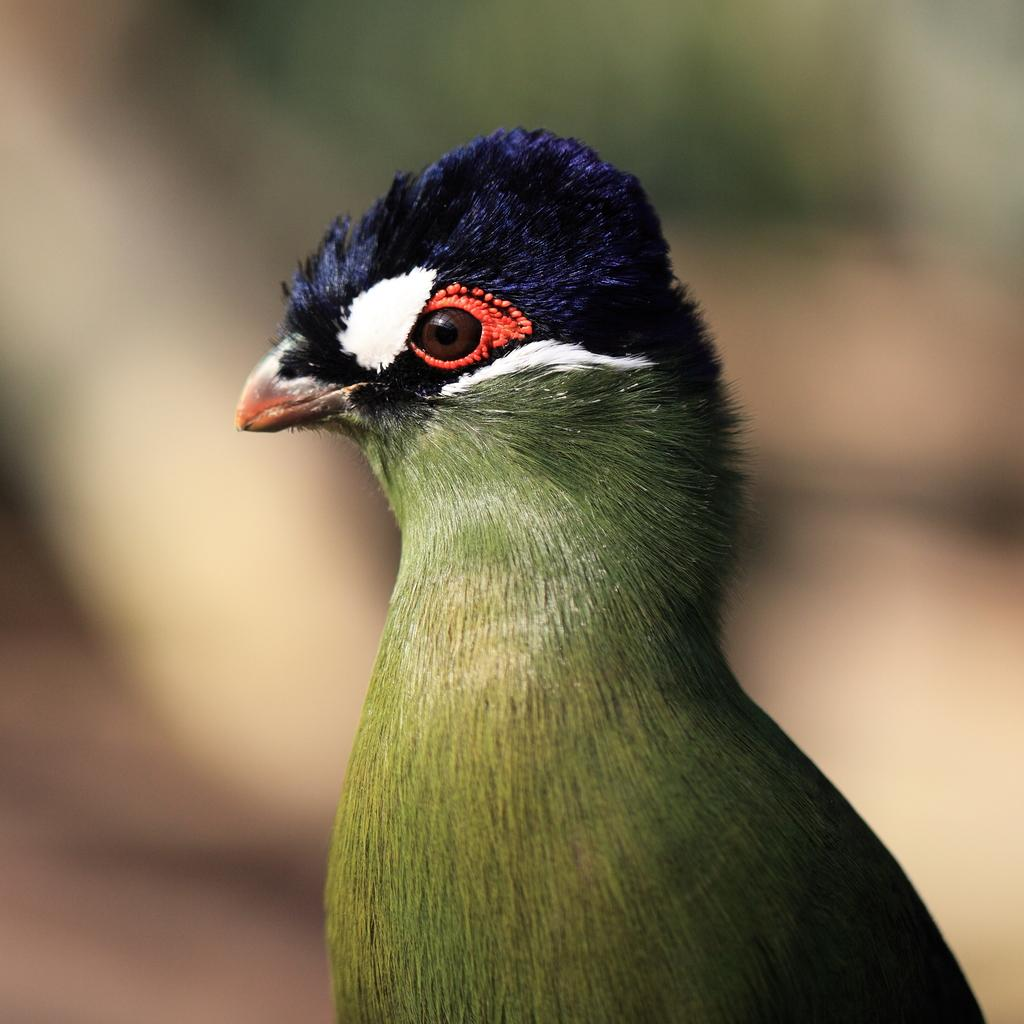What type of animal is present in the image? There is a bird in the image. Can you describe the background of the image? The background of the image is blurry. What type of joke is being told at the party in the image? There is no party or joke present in the image; it features a bird with a blurry background. Where is the vase located in the image? There is no vase present in the image. 